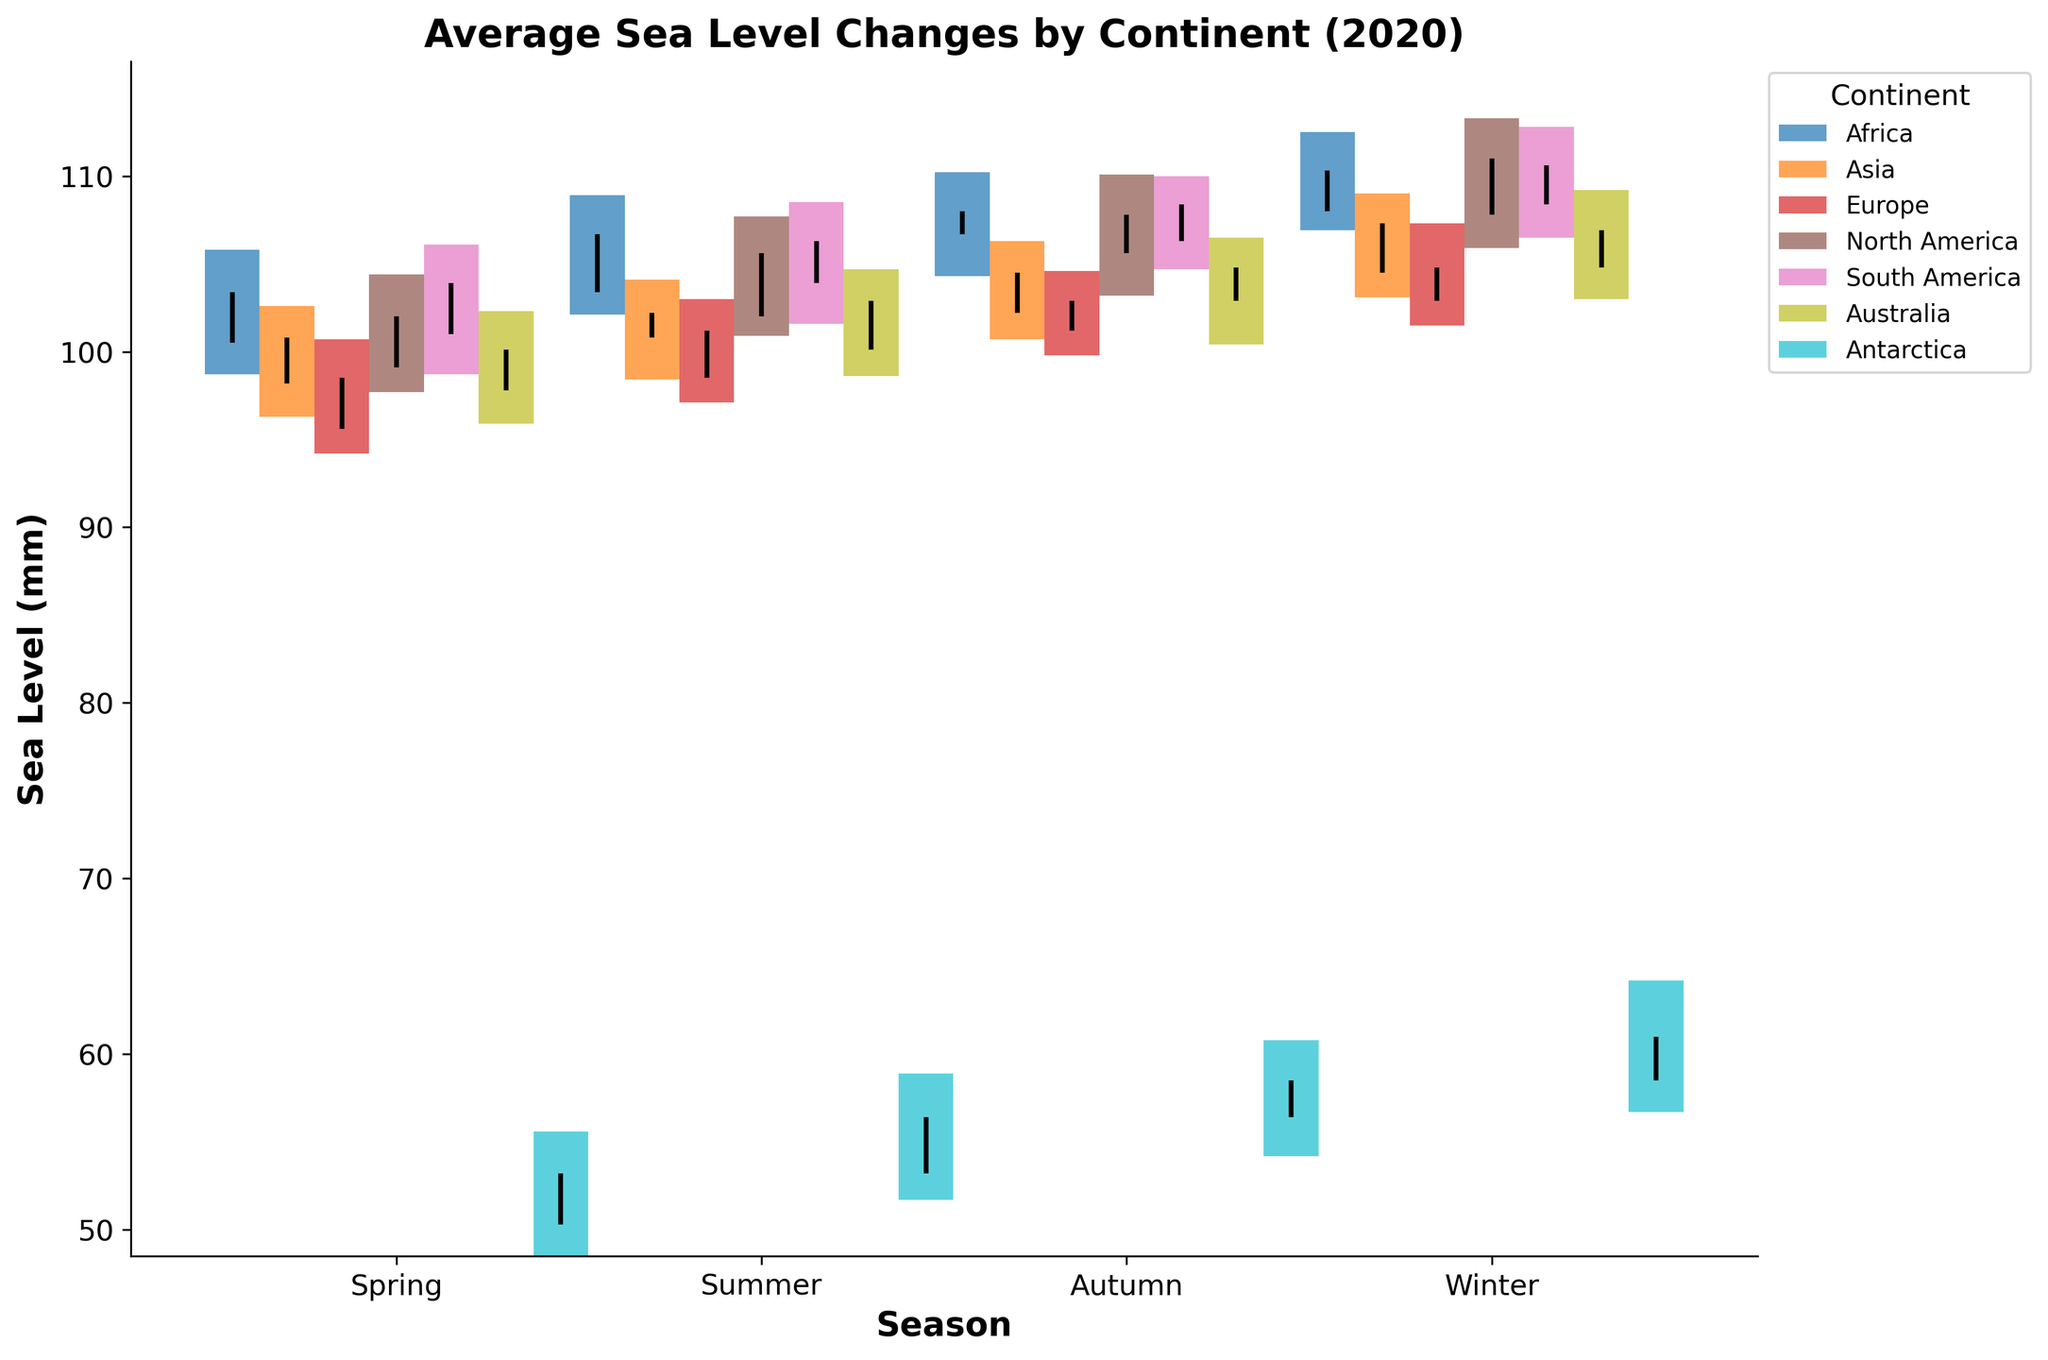What's the title of the figure? The title is typically located at the top of the figure. By looking at the top, you can identify the text in a larger font and often bold.
Answer: Average Sea Level Changes by Continent (2020) What are the x-axis labels? The x-axis labels represent the seasons. These labels can be found at the bottom of the figure on the x-axis.
Answer: Spring, Summer, Autumn, and Winter Which continent shows the highest sea level in Winter? To find this, observe the highest bar end and vline in the winter section for each continent. The highest sea level corresponds to the top of Antarctica's winter bar ending at 64.2 mm.
Answer: Antarctica During which season does North America have the lowest sea level? Look at North America's data for each season and identify the bottom of their bars. The lowest starting point for North America is during the Spring season at 99.1 mm.
Answer: Spring In which season does Europe experience the highest sea level? To determine this, examine Europe’s data for all seasons and find the highest reach of the bars or vline ends. Europe’s winter season has the highest sea level, topping at 107.3 mm.
Answer: Winter What is the range of sea level variations in South America during Autumn? The range is the difference between the high and low values within a season. For South America in Autumn, this is 110.0 mm (High) - 104.7 mm (Low) = 5.3 mm.
Answer: 5.3 mm Which continent shows the smallest variation in sea level during Summer? Find the difference between the high and low values for all continents during summer. Antarctica shows the smallest variation: 58.9 mm - 51.7 mm = 7.2 mm.
Answer: Antarctica Compare the starting sea levels of Asia in Spring and Autumn. Which one is higher? Compare the start sea level in Spring (98.2 mm) and Autumn (102.2 mm). The sea level in Autumn is higher.
Answer: Autumn Between Africa and Australia, which continent has a higher ending sea level in Autumn? Look at the end sea level for Africa (108.0 mm) and Australia (104.8 mm) in Autumn. Africa has a higher ending sea level.
Answer: Africa 